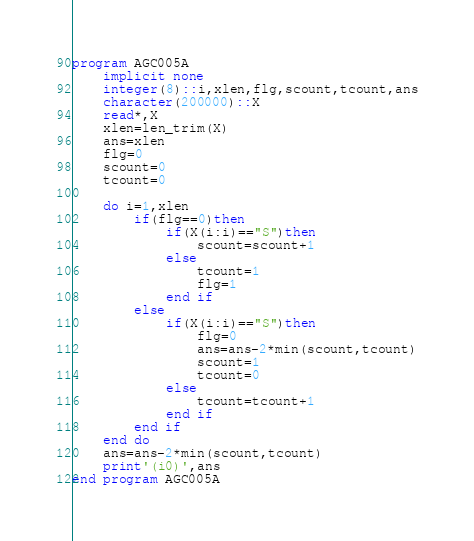Convert code to text. <code><loc_0><loc_0><loc_500><loc_500><_FORTRAN_>program AGC005A
    implicit none
    integer(8)::i,xlen,flg,scount,tcount,ans
    character(200000)::X
    read*,X
    xlen=len_trim(X)
    ans=xlen
    flg=0
    scount=0
    tcount=0

    do i=1,xlen
        if(flg==0)then
            if(X(i:i)=="S")then
                scount=scount+1
            else
                tcount=1
                flg=1
            end if
        else
            if(X(i:i)=="S")then
                flg=0
                ans=ans-2*min(scount,tcount)
                scount=1
                tcount=0
            else
                tcount=tcount+1
            end if
        end if
    end do
    ans=ans-2*min(scount,tcount)
    print'(i0)',ans
end program AGC005A</code> 